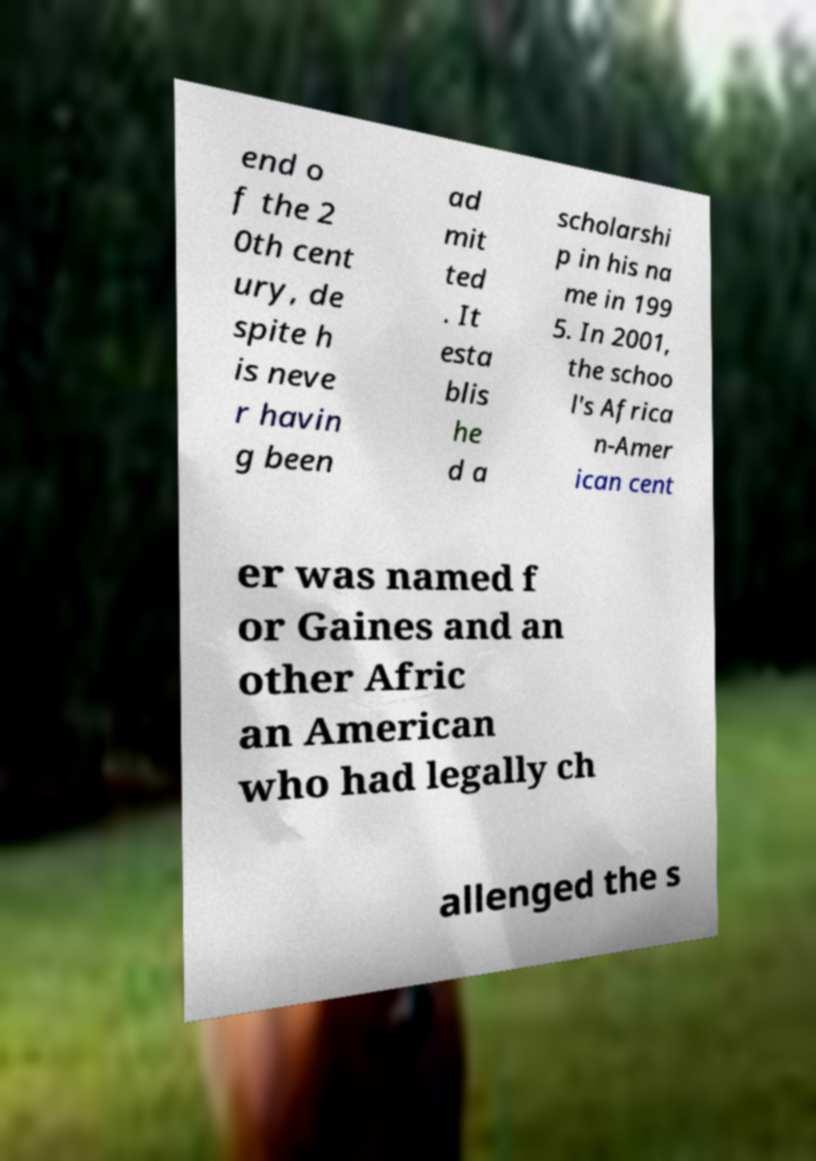Can you accurately transcribe the text from the provided image for me? end o f the 2 0th cent ury, de spite h is neve r havin g been ad mit ted . It esta blis he d a scholarshi p in his na me in 199 5. In 2001, the schoo l's Africa n-Amer ican cent er was named f or Gaines and an other Afric an American who had legally ch allenged the s 